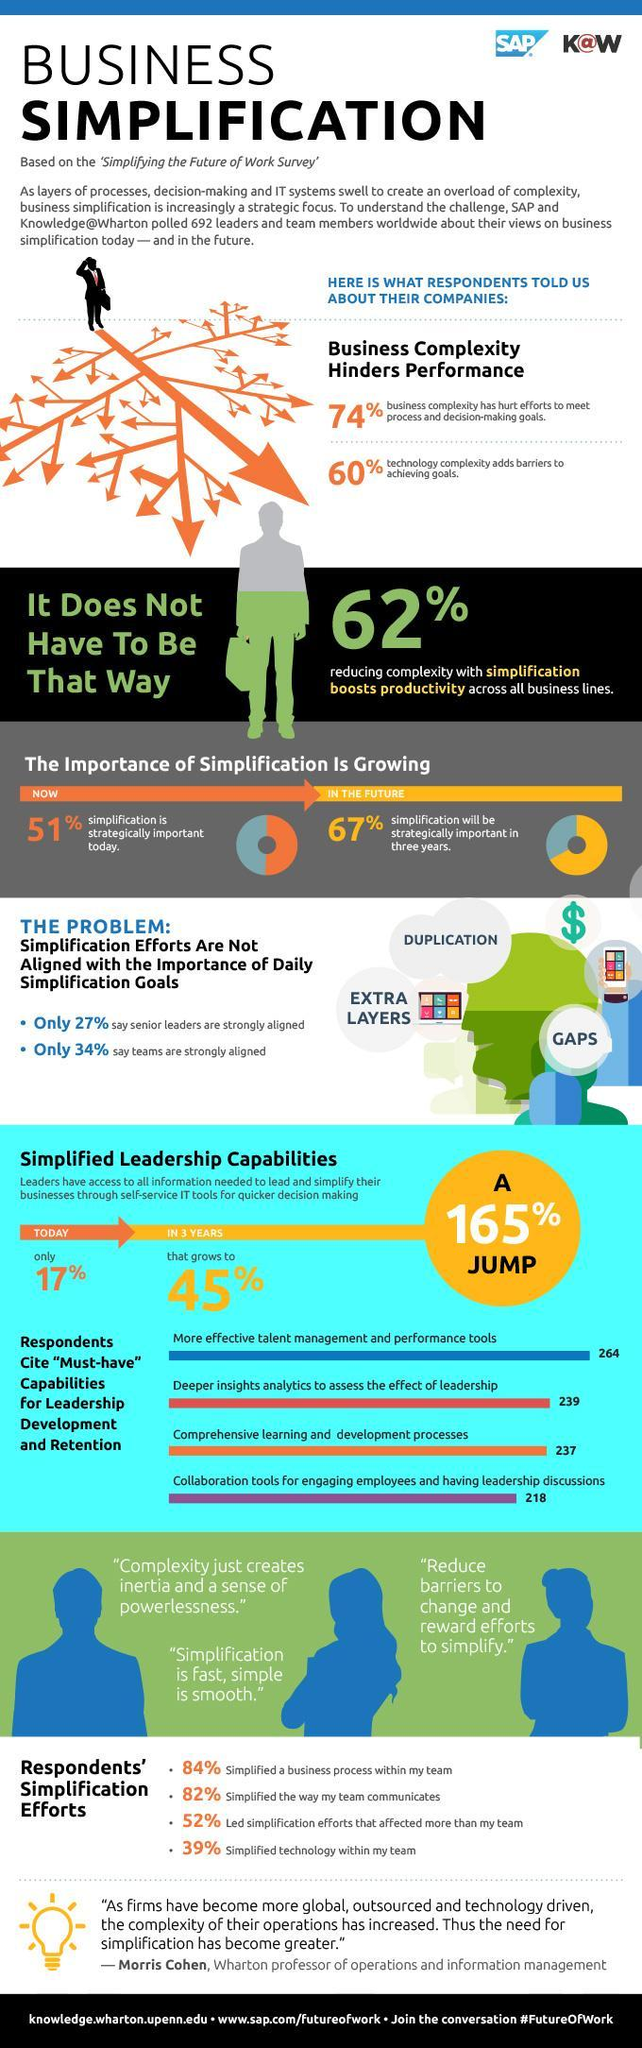What is the first capability cited by respondents as required for leadership development?
Answer the question with a short phrase. more effective talent management and performance tools What percent of people believe simplification is important in the future 67% How many people cited Deeper insight analytics to assess leadership effects are required? 239 